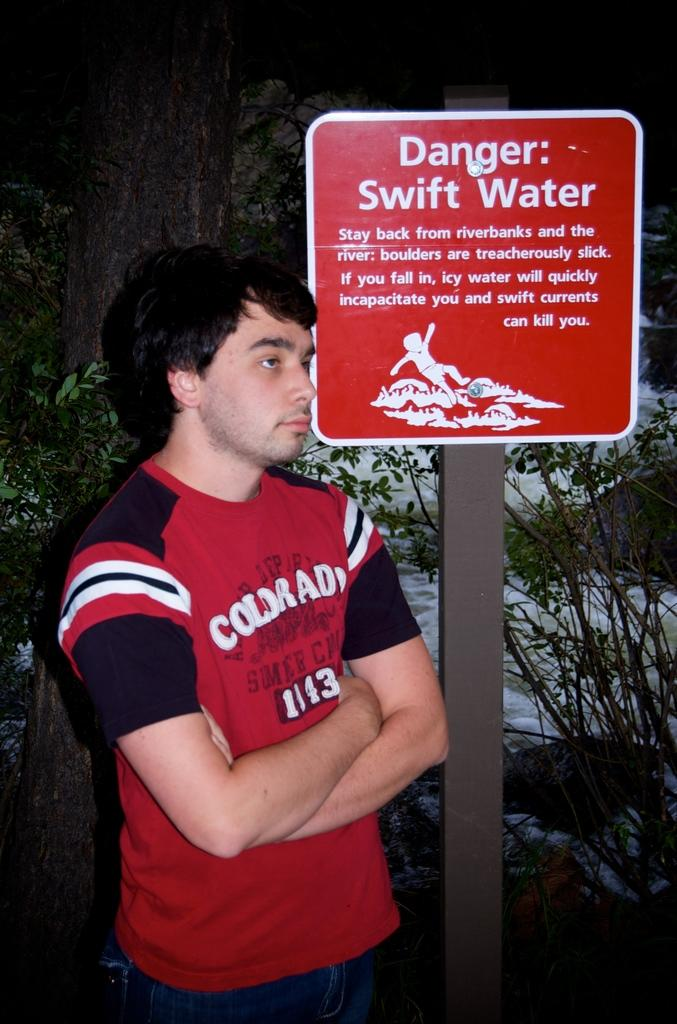<image>
Present a compact description of the photo's key features. A person wearing a red shirt stands by a sign warning people of swift water. 